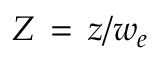Convert formula to latex. <formula><loc_0><loc_0><loc_500><loc_500>Z \, = \, z / w _ { e }</formula> 